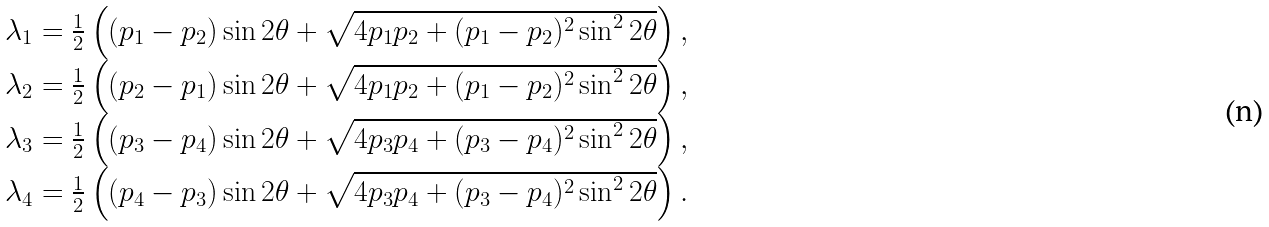<formula> <loc_0><loc_0><loc_500><loc_500>\begin{array} { c } \lambda _ { 1 } = \frac { 1 } { 2 } \left ( ( p _ { 1 } - p _ { 2 } ) \sin { 2 \theta } + \sqrt { 4 p _ { 1 } p _ { 2 } + ( p _ { 1 } - p _ { 2 } ) ^ { 2 } \sin ^ { 2 } { 2 \theta } } \right ) , \\ \lambda _ { 2 } = \frac { 1 } { 2 } \left ( ( p _ { 2 } - p _ { 1 } ) \sin { 2 \theta } + \sqrt { 4 p _ { 1 } p _ { 2 } + ( p _ { 1 } - p _ { 2 } ) ^ { 2 } \sin ^ { 2 } { 2 \theta } } \right ) , \\ \lambda _ { 3 } = \frac { 1 } { 2 } \left ( ( p _ { 3 } - p _ { 4 } ) \sin { 2 \theta } + \sqrt { 4 p _ { 3 } p _ { 4 } + ( p _ { 3 } - p _ { 4 } ) ^ { 2 } \sin ^ { 2 } { 2 \theta } } \right ) , \\ \lambda _ { 4 } = \frac { 1 } { 2 } \left ( ( p _ { 4 } - p _ { 3 } ) \sin { 2 \theta } + \sqrt { 4 p _ { 3 } p _ { 4 } + ( p _ { 3 } - p _ { 4 } ) ^ { 2 } \sin ^ { 2 } { 2 \theta } } \right ) . \end{array}</formula> 